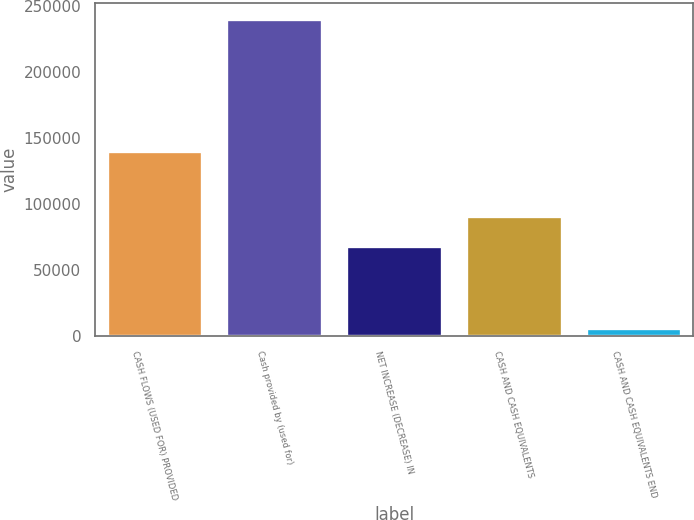Convert chart. <chart><loc_0><loc_0><loc_500><loc_500><bar_chart><fcel>CASH FLOWS (USED FOR) PROVIDED<fcel>Cash provided by (used for)<fcel>NET INCREASE (DECREASE) IN<fcel>CASH AND CASH EQUIVALENTS<fcel>CASH AND CASH EQUIVALENTS END<nl><fcel>139876<fcel>240068<fcel>67946.4<fcel>91335.8<fcel>6174<nl></chart> 